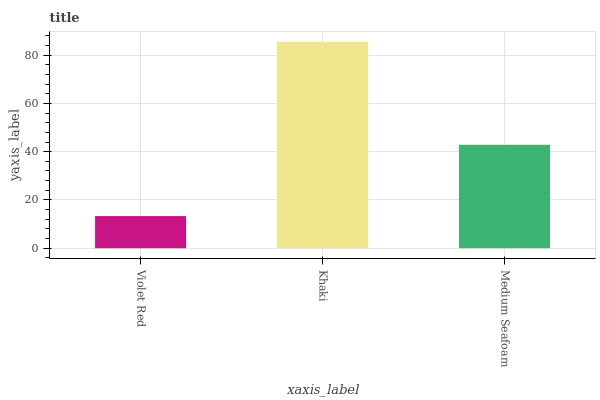Is Violet Red the minimum?
Answer yes or no. Yes. Is Khaki the maximum?
Answer yes or no. Yes. Is Medium Seafoam the minimum?
Answer yes or no. No. Is Medium Seafoam the maximum?
Answer yes or no. No. Is Khaki greater than Medium Seafoam?
Answer yes or no. Yes. Is Medium Seafoam less than Khaki?
Answer yes or no. Yes. Is Medium Seafoam greater than Khaki?
Answer yes or no. No. Is Khaki less than Medium Seafoam?
Answer yes or no. No. Is Medium Seafoam the high median?
Answer yes or no. Yes. Is Medium Seafoam the low median?
Answer yes or no. Yes. Is Khaki the high median?
Answer yes or no. No. Is Khaki the low median?
Answer yes or no. No. 